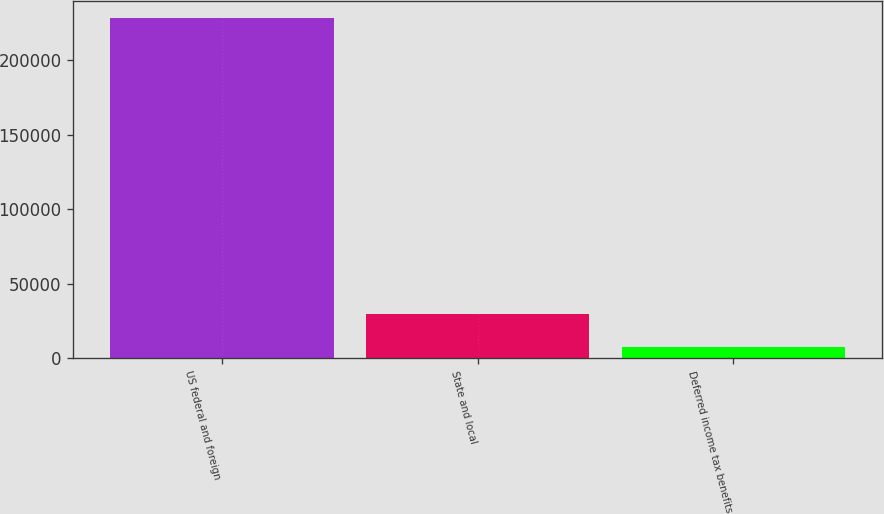Convert chart. <chart><loc_0><loc_0><loc_500><loc_500><bar_chart><fcel>US federal and foreign<fcel>State and local<fcel>Deferred income tax benefits<nl><fcel>228159<fcel>29222.1<fcel>7118<nl></chart> 